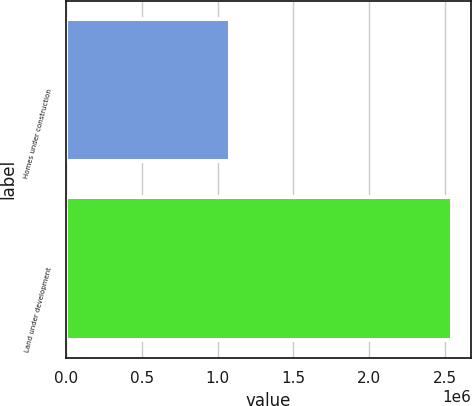Convert chart. <chart><loc_0><loc_0><loc_500><loc_500><bar_chart><fcel>Homes under construction<fcel>Land under development<nl><fcel>1.08414e+06<fcel>2.54505e+06<nl></chart> 